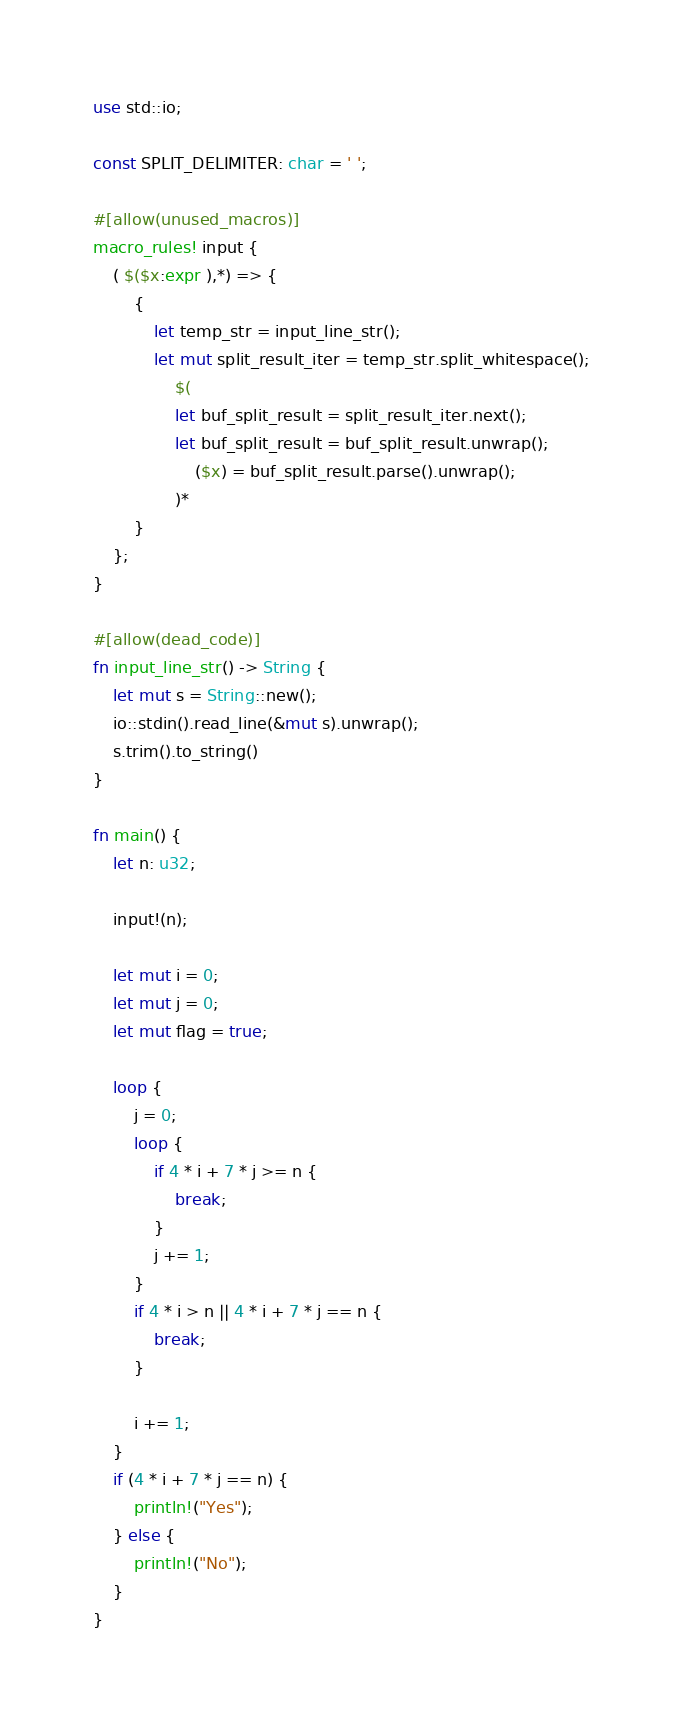<code> <loc_0><loc_0><loc_500><loc_500><_Rust_>use std::io;

const SPLIT_DELIMITER: char = ' ';

#[allow(unused_macros)]
macro_rules! input {
    ( $($x:expr ),*) => {
        {
            let temp_str = input_line_str();
            let mut split_result_iter = temp_str.split_whitespace();
                $(
                let buf_split_result = split_result_iter.next();
                let buf_split_result = buf_split_result.unwrap();
                    ($x) = buf_split_result.parse().unwrap();
                )*
        }
    };
}

#[allow(dead_code)]
fn input_line_str() -> String {
    let mut s = String::new();
    io::stdin().read_line(&mut s).unwrap();
    s.trim().to_string()
}

fn main() {
    let n: u32;

    input!(n);

    let mut i = 0;
    let mut j = 0;
    let mut flag = true;

    loop {
        j = 0;
        loop {
            if 4 * i + 7 * j >= n {
                break;
            }
            j += 1;
        }
        if 4 * i > n || 4 * i + 7 * j == n {
            break;
        }

        i += 1;
    }
    if (4 * i + 7 * j == n) {
        println!("Yes");
    } else {
        println!("No");
    }
}</code> 